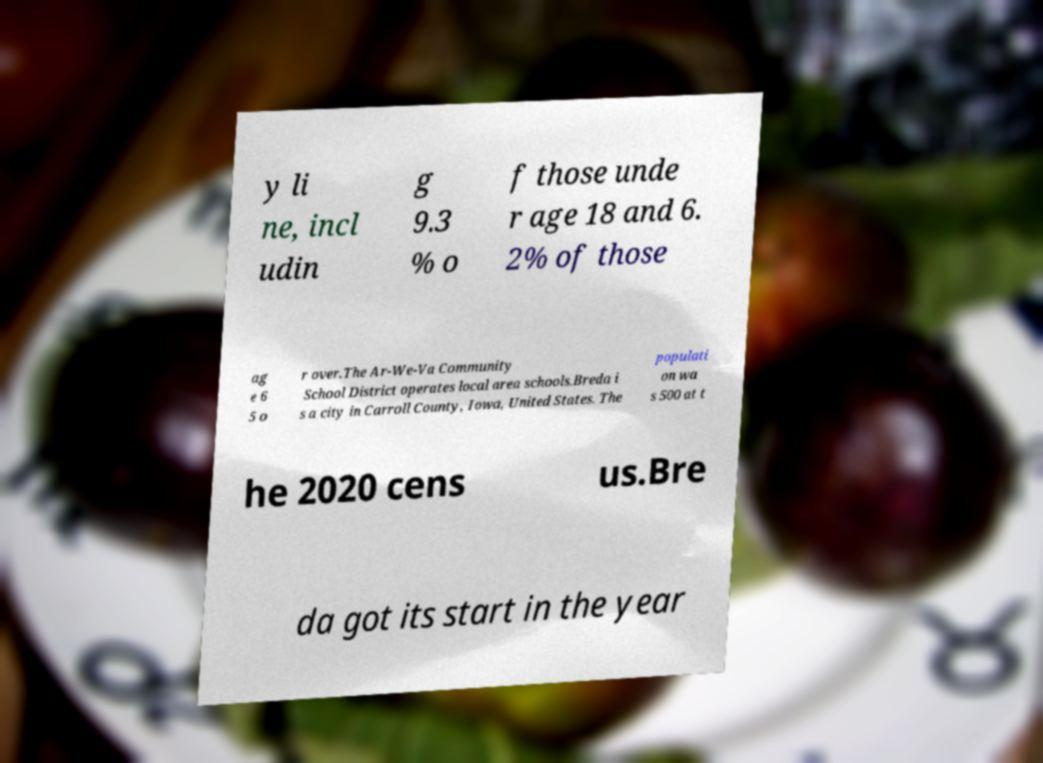Could you extract and type out the text from this image? y li ne, incl udin g 9.3 % o f those unde r age 18 and 6. 2% of those ag e 6 5 o r over.The Ar-We-Va Community School District operates local area schools.Breda i s a city in Carroll County, Iowa, United States. The populati on wa s 500 at t he 2020 cens us.Bre da got its start in the year 